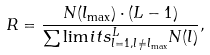Convert formula to latex. <formula><loc_0><loc_0><loc_500><loc_500>R = \frac { N ( l _ { \max } ) \cdot ( L - 1 ) } { \sum \lim i t s _ { l = 1 , l \neq l _ { \max } } ^ { L } N ( l ) } ,</formula> 